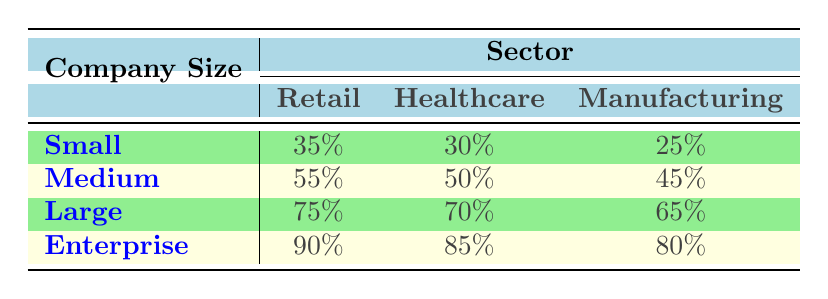What is the AI adoption rate for small retail companies? Referring to the table, the AI adoption rate for small retail companies is listed as 35%.
Answer: 35% Which company size has the highest AI adoption rate in the healthcare sector? Looking at the healthcare sector, the enterprise company size has the highest AI adoption rate at 85%.
Answer: 85% What is the difference in AI adoption rates between medium-sized and small manufacturing companies? The AI adoption rate for medium manufacturing companies is 45%, while for small manufacturing companies, it is 25%. The difference is 45 - 25 = 20%.
Answer: 20% True or False: Large companies have a higher AI adoption rate in retail than small companies. In the table, large companies have a rate of 75% in retail compared to small companies' rate of 35%. Therefore, the statement is true.
Answer: True What is the average AI adoption rate across all sectors for large companies? The rates for large companies in each sector are as follows: retail 75%, healthcare 70%, and manufacturing 65%. The sum is 75 + 70 + 65 = 210. Dividing by 3 sectors gives an average of 210/3 = 70%.
Answer: 70% Which sector has the lowest AI adoption rate among small companies? The table shows the AI adoption rates for small companies: retail 35%, healthcare 30%, and manufacturing 25%. The lowest rate is in manufacturing at 25%.
Answer: 25% Is the AI adoption rate for medium-sized companies in healthcare greater than the rate for large companies in manufacturing? The adoption rate is 50% for medium healthcare companies and 65% for large manufacturing companies. Since 50% is less than 65%, the statement is false.
Answer: False Which company size and sector combination shows the second highest AI adoption rate? Looking at the table, the combination with the highest rate is enterprise retail at 90%, followed by large retail at 75%. Therefore, the second highest is large retail at 75%.
Answer: 75% 